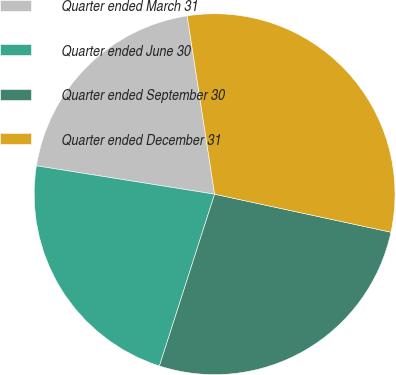<chart> <loc_0><loc_0><loc_500><loc_500><pie_chart><fcel>Quarter ended March 31<fcel>Quarter ended June 30<fcel>Quarter ended September 30<fcel>Quarter ended December 31<nl><fcel>20.06%<fcel>22.57%<fcel>26.57%<fcel>30.81%<nl></chart> 